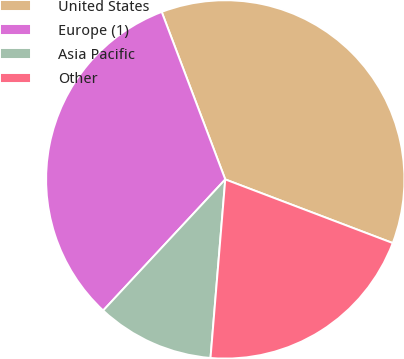<chart> <loc_0><loc_0><loc_500><loc_500><pie_chart><fcel>United States<fcel>Europe (1)<fcel>Asia Pacific<fcel>Other<nl><fcel>36.55%<fcel>32.29%<fcel>10.62%<fcel>20.53%<nl></chart> 